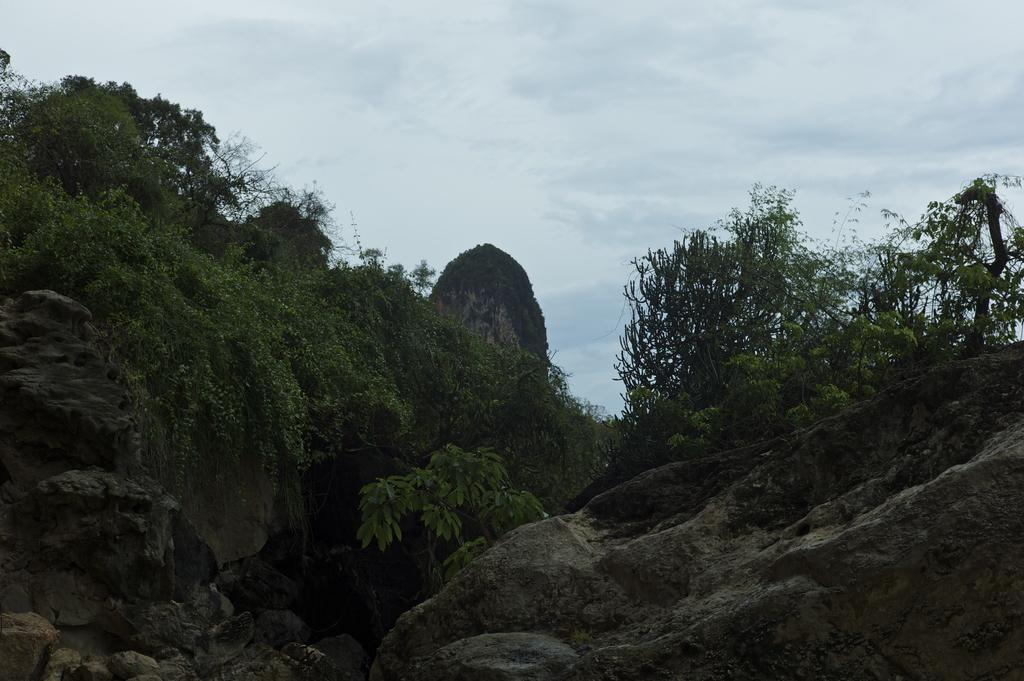What is the main subject in the image? There is a rock in the image. What else can be seen in the image besides the rock? There are plants in the image. What is the color of the plants? The plants are green. What is visible in the background of the image? The sky is visible in the background of the image. What are the colors of the sky in the image? The sky is blue and white in color. Can you tell me how the rock is breathing in the image? Rocks do not breathe, so this question cannot be answered based on the image. 